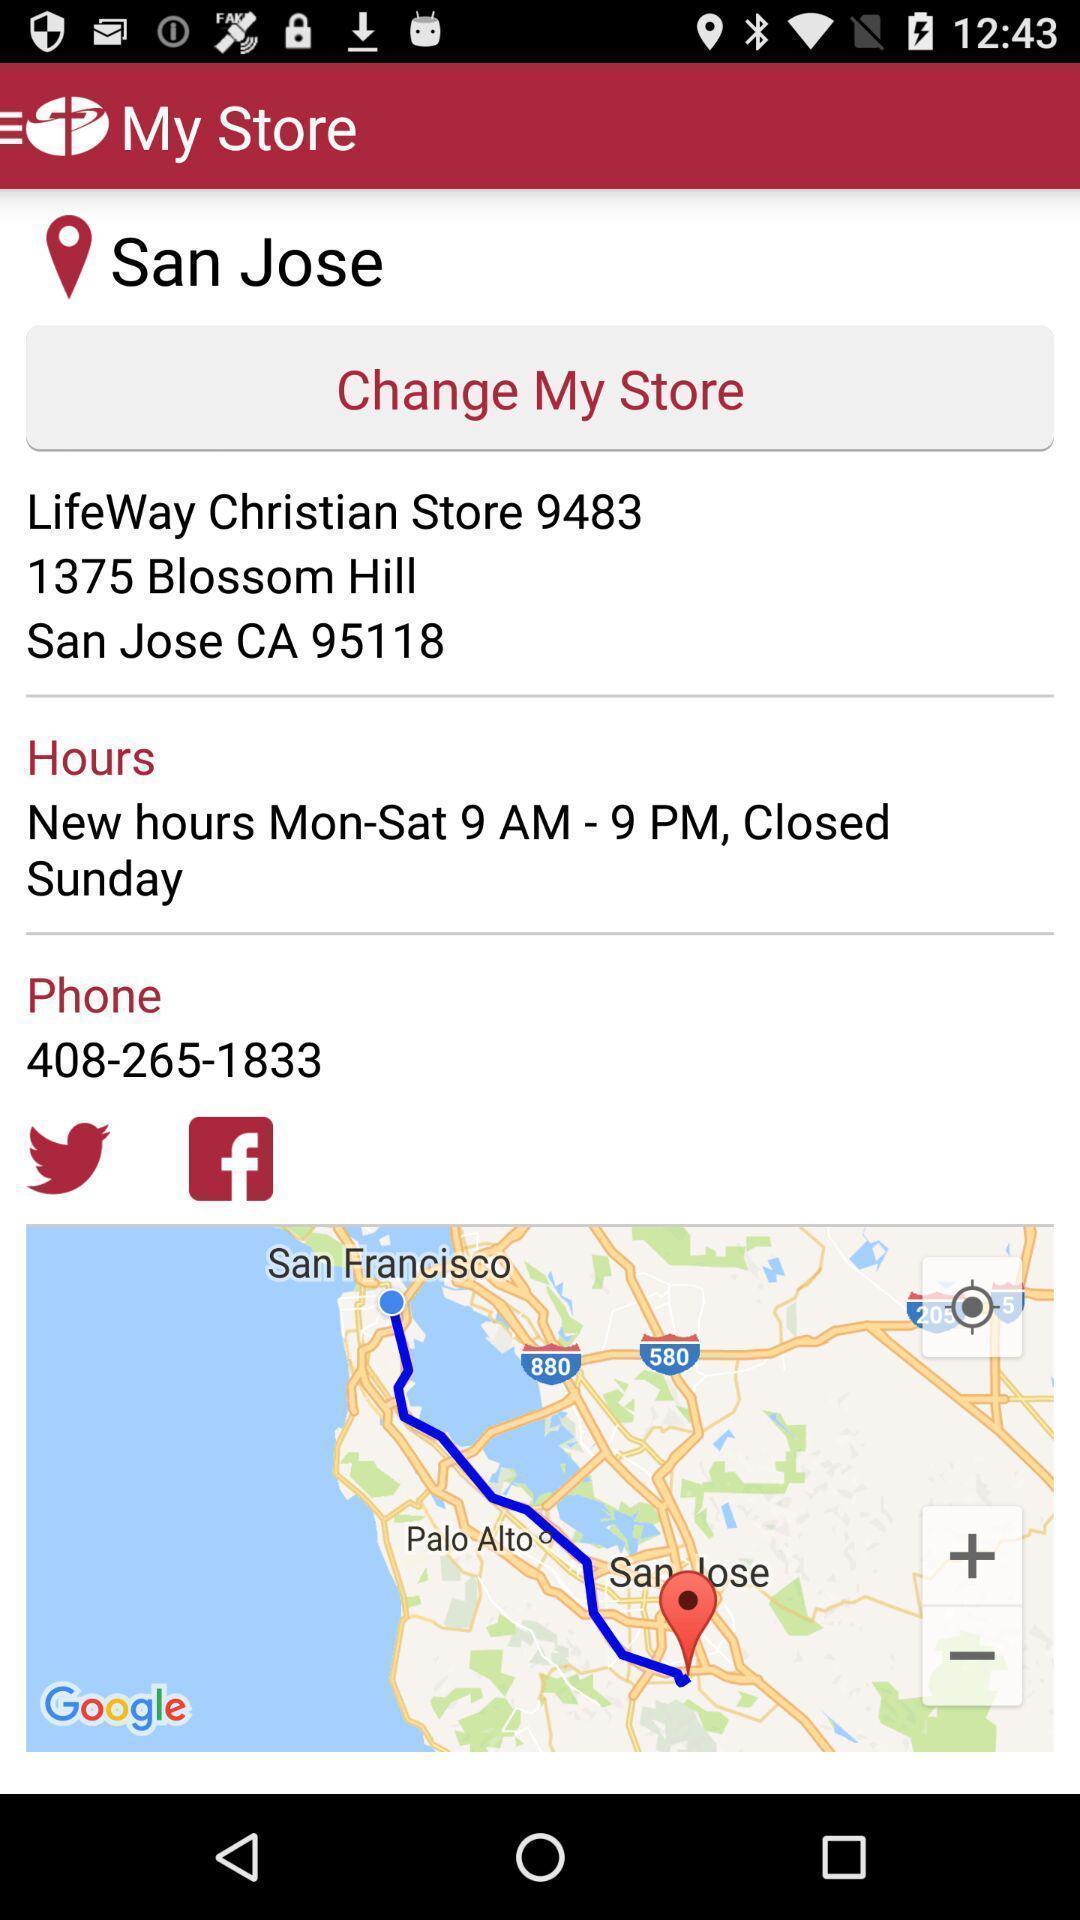Summarize the information in this screenshot. Route map of a place and details in mapping app. 